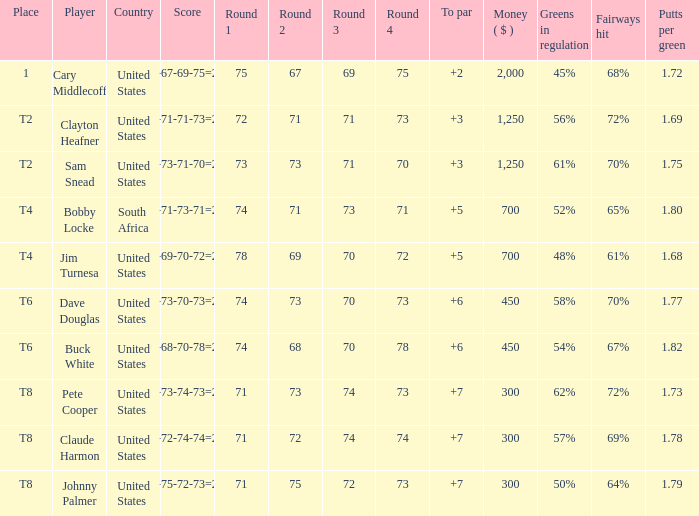What is Claude Harmon's Place? T8. 